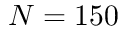Convert formula to latex. <formula><loc_0><loc_0><loc_500><loc_500>N = 1 5 0</formula> 